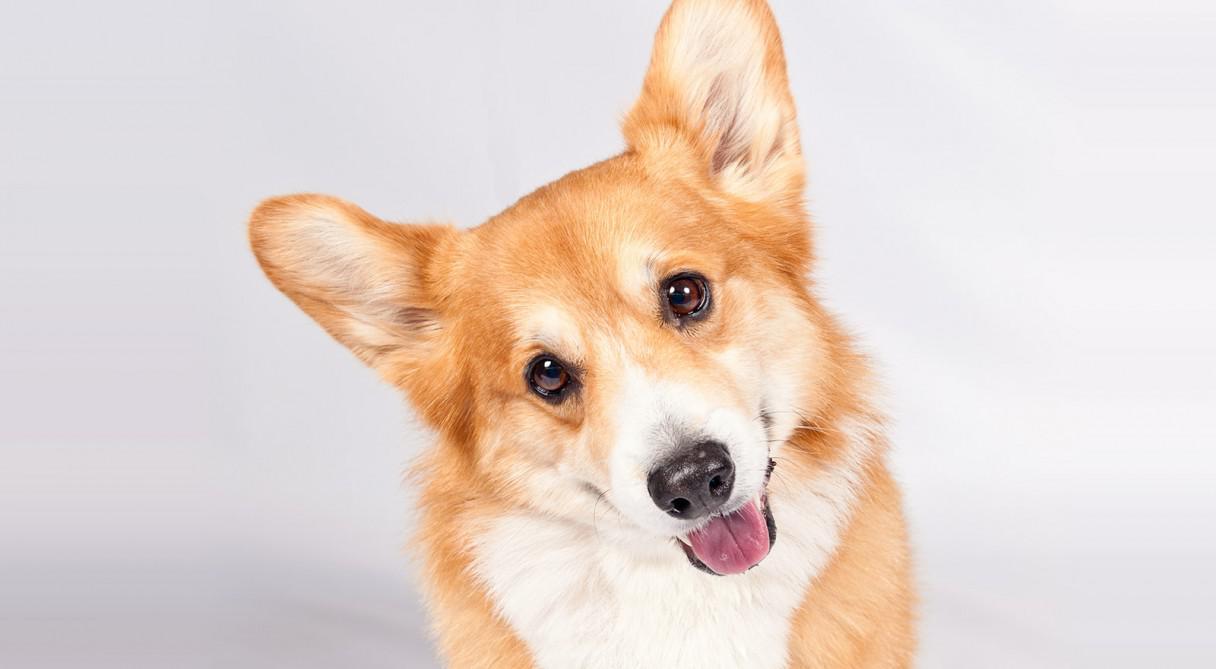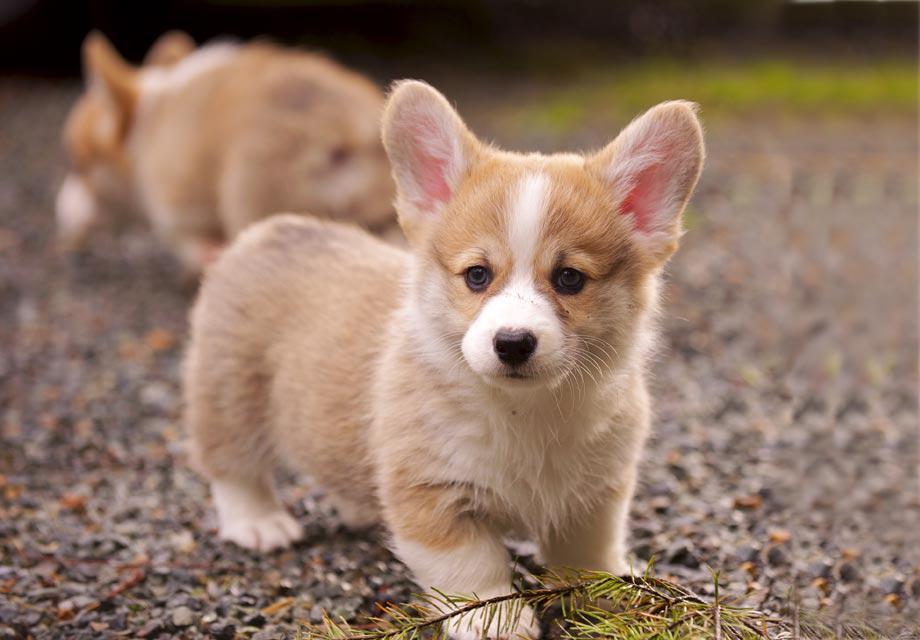The first image is the image on the left, the second image is the image on the right. Examine the images to the left and right. Is the description "In one of the image there is a dog standing in the grass." accurate? Answer yes or no. No. The first image is the image on the left, the second image is the image on the right. Considering the images on both sides, is "The image on the right has one dog with a collar exposed." valid? Answer yes or no. No. 